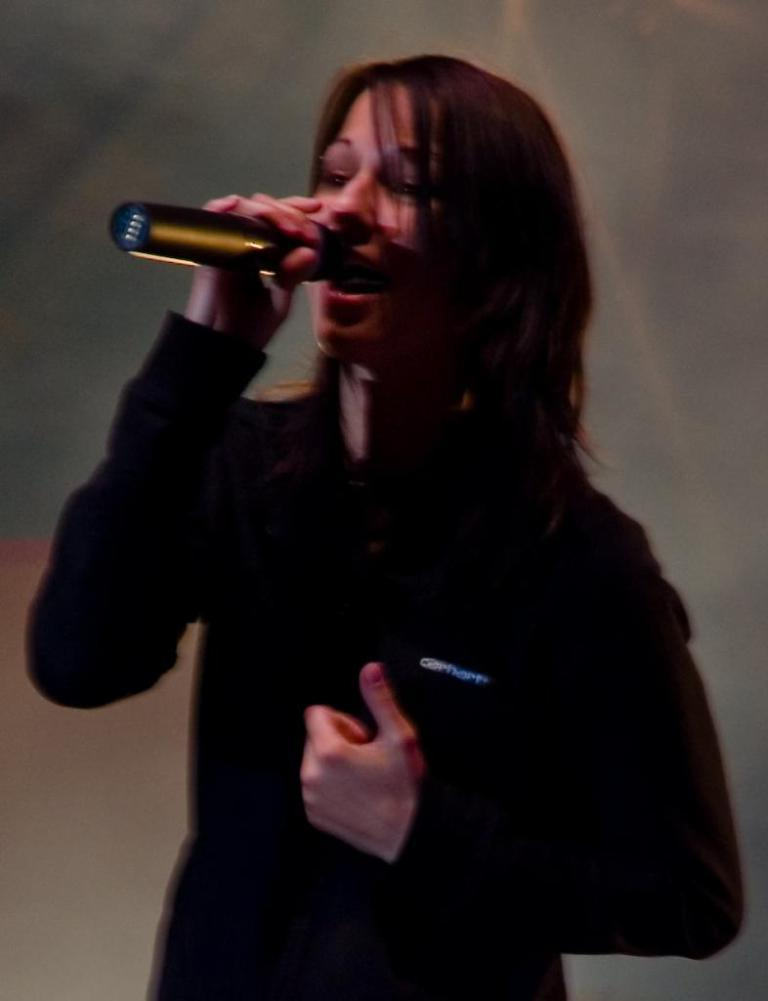Who is the main subject in the image? There is a woman in the image. What is the woman wearing? The woman is wearing a black dress. What is the woman doing in the image? The woman is standing and holding a black microphone. Can you describe the background of the image? The background of the image is blurry. What type of weather can be seen in the image? There is no indication of weather in the image, as it is focused on the woman and her surroundings are blurry. 